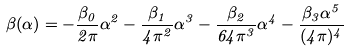<formula> <loc_0><loc_0><loc_500><loc_500>\beta ( \alpha ) = - \frac { \beta _ { 0 } } { 2 \pi } \alpha ^ { 2 } - \frac { \beta _ { 1 } } { 4 \pi ^ { 2 } } \alpha ^ { 3 } - \frac { \beta _ { 2 } } { 6 4 \pi ^ { 3 } } \alpha ^ { 4 } - \frac { \beta _ { 3 } \alpha ^ { 5 } } { ( 4 \pi ) ^ { 4 } }</formula> 